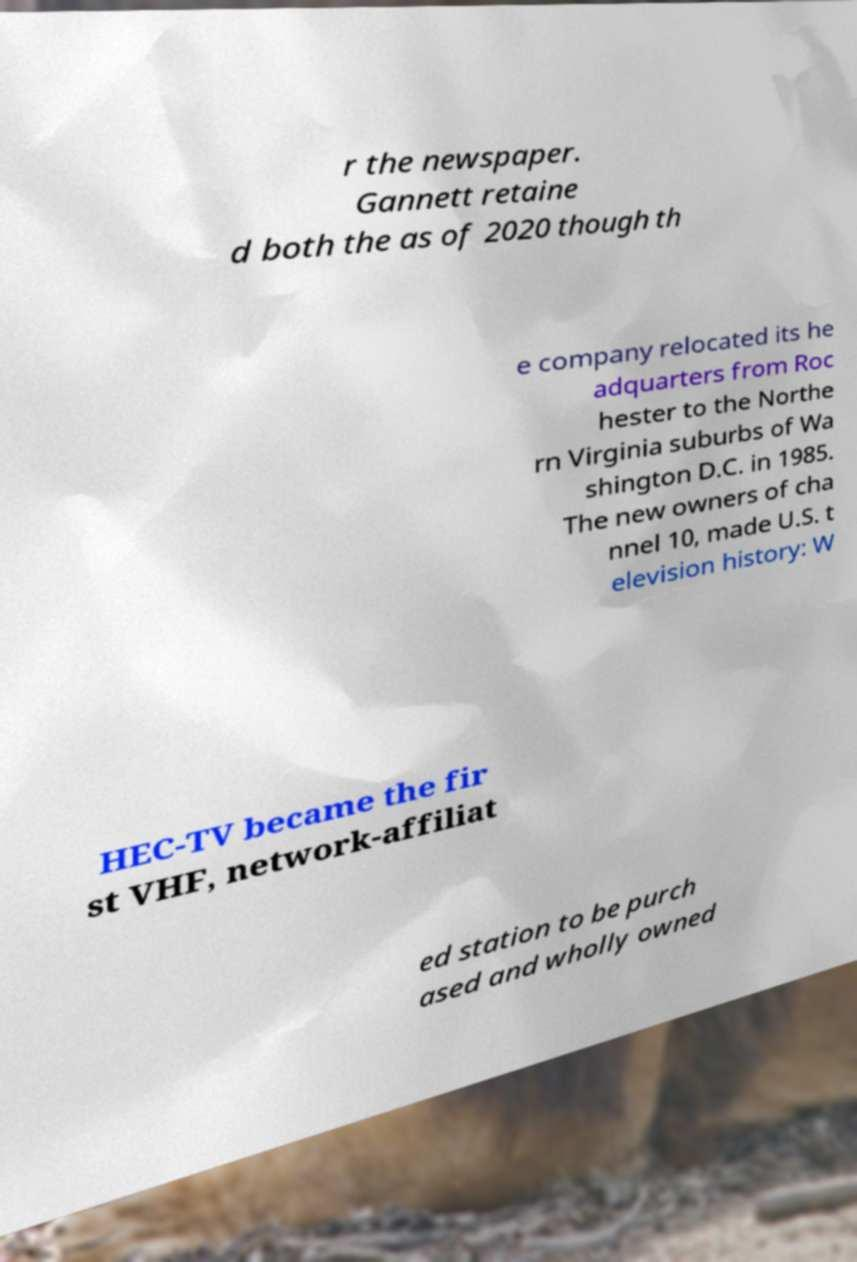Can you read and provide the text displayed in the image?This photo seems to have some interesting text. Can you extract and type it out for me? r the newspaper. Gannett retaine d both the as of 2020 though th e company relocated its he adquarters from Roc hester to the Northe rn Virginia suburbs of Wa shington D.C. in 1985. The new owners of cha nnel 10, made U.S. t elevision history: W HEC-TV became the fir st VHF, network-affiliat ed station to be purch ased and wholly owned 